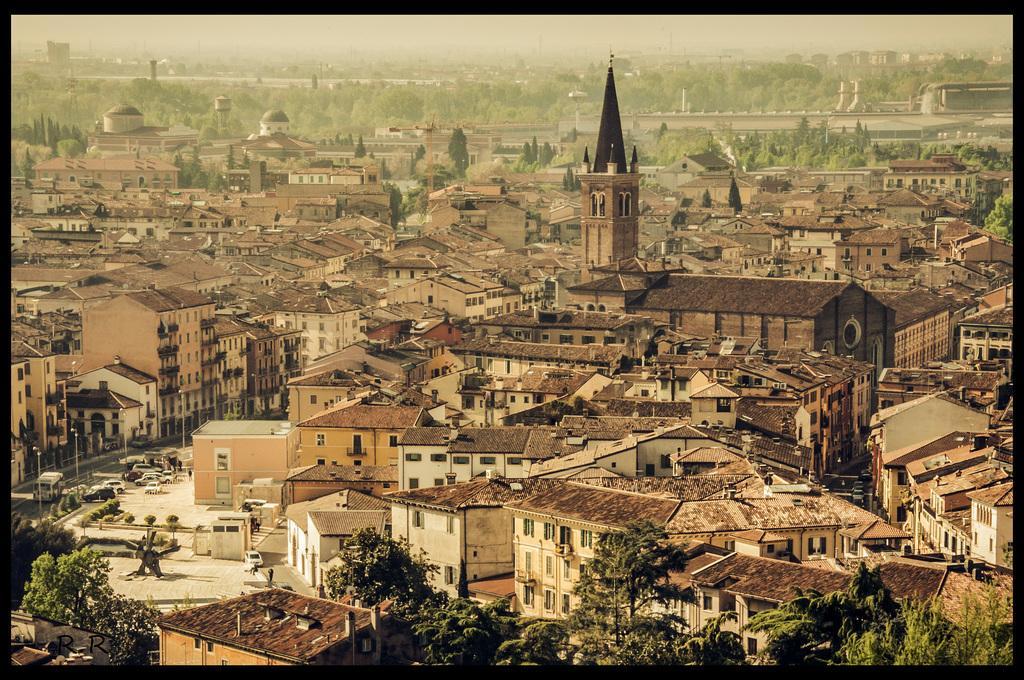In one or two sentences, can you explain what this image depicts? In this image we can see the picture of a group of buildings, towers, some vehicles on the road, street poles, a group of trees and the sky. 